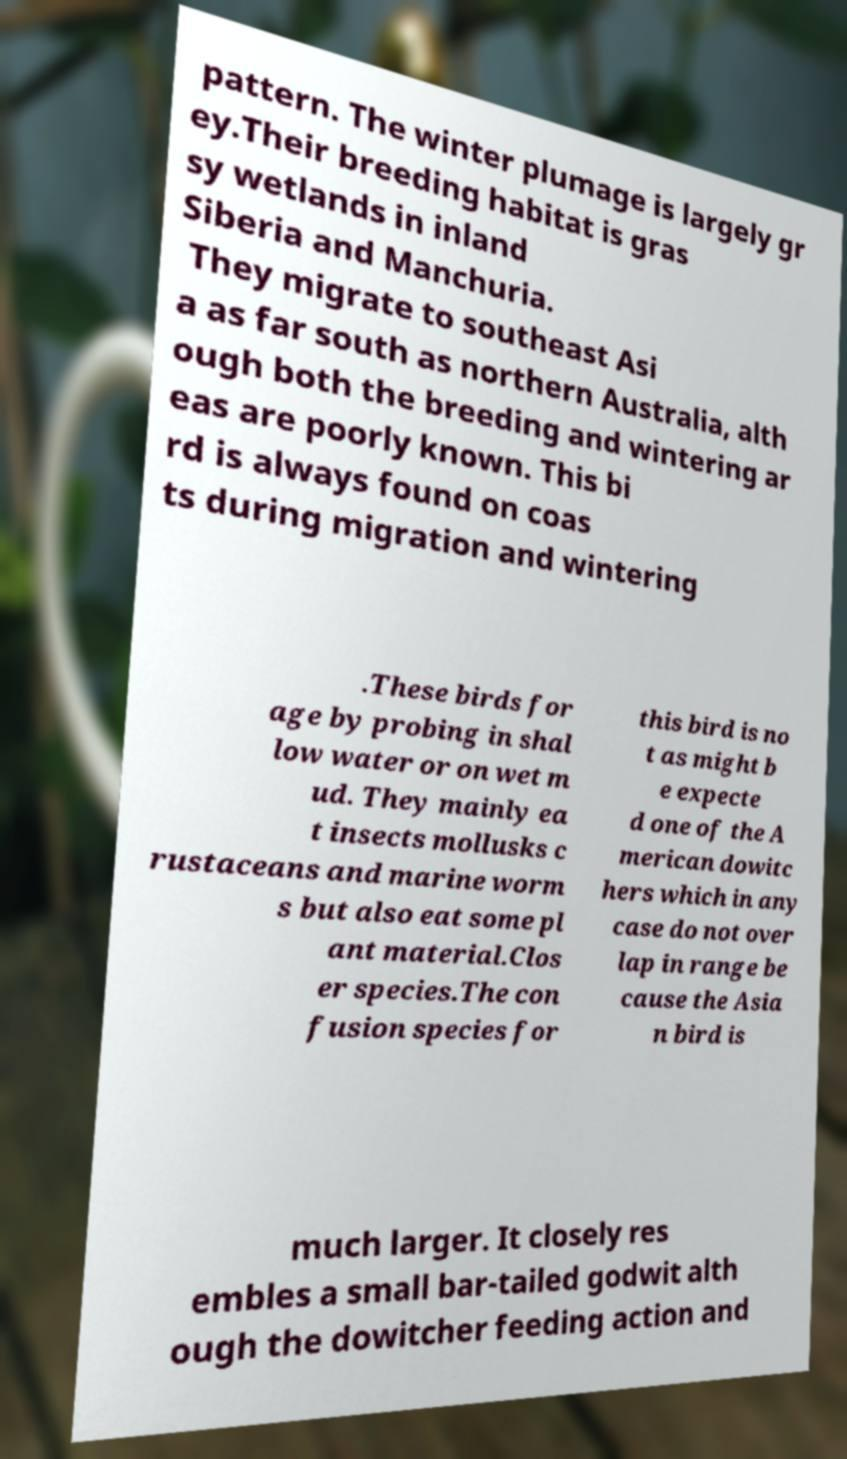There's text embedded in this image that I need extracted. Can you transcribe it verbatim? pattern. The winter plumage is largely gr ey.Their breeding habitat is gras sy wetlands in inland Siberia and Manchuria. They migrate to southeast Asi a as far south as northern Australia, alth ough both the breeding and wintering ar eas are poorly known. This bi rd is always found on coas ts during migration and wintering .These birds for age by probing in shal low water or on wet m ud. They mainly ea t insects mollusks c rustaceans and marine worm s but also eat some pl ant material.Clos er species.The con fusion species for this bird is no t as might b e expecte d one of the A merican dowitc hers which in any case do not over lap in range be cause the Asia n bird is much larger. It closely res embles a small bar-tailed godwit alth ough the dowitcher feeding action and 